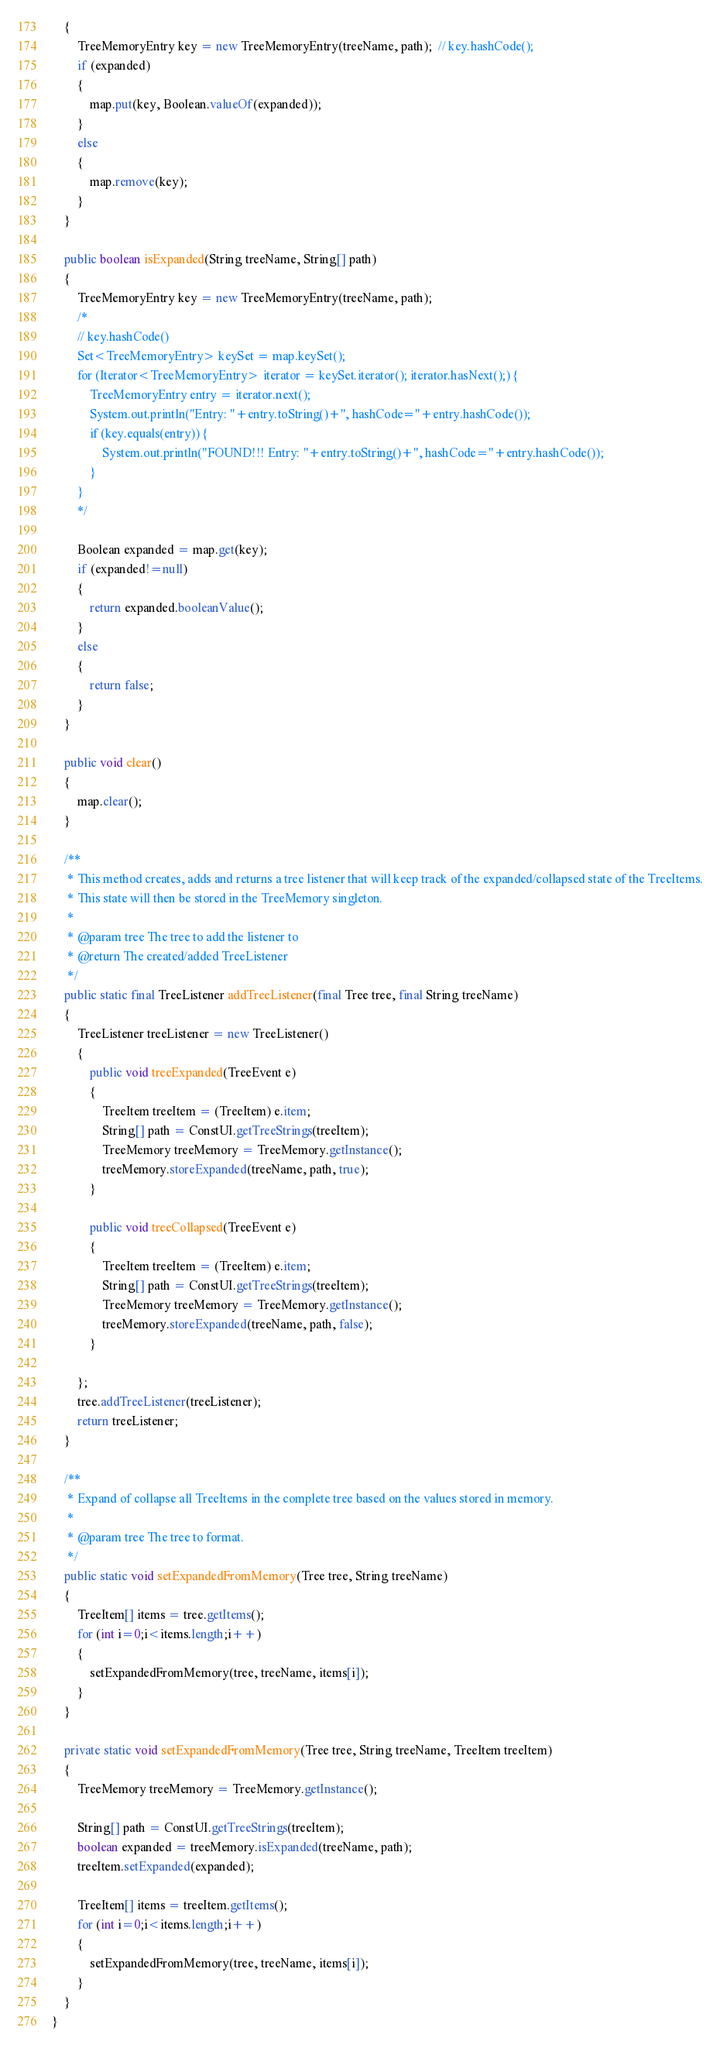<code> <loc_0><loc_0><loc_500><loc_500><_Java_>    {
    	TreeMemoryEntry key = new TreeMemoryEntry(treeName, path);  // key.hashCode();
        if (expanded)
        {
            map.put(key, Boolean.valueOf(expanded));
        }
        else
        {
            map.remove(key);
        }
    }
    
    public boolean isExpanded(String treeName, String[] path)
    {
    	TreeMemoryEntry key = new TreeMemoryEntry(treeName, path);
    	/*
    	// key.hashCode()
    	Set<TreeMemoryEntry> keySet = map.keySet();
    	for (Iterator<TreeMemoryEntry> iterator = keySet.iterator(); iterator.hasNext();) {
			TreeMemoryEntry entry = iterator.next();
			System.out.println("Entry: "+entry.toString()+", hashCode="+entry.hashCode());
			if (key.equals(entry)) {
				System.out.println("FOUND!!! Entry: "+entry.toString()+", hashCode="+entry.hashCode());
			}
		}
    	*/
    	
    	Boolean expanded = map.get(key);
        if (expanded!=null)
        {
            return expanded.booleanValue();
        }
        else
        {
            return false;
        }
    }
    
    public void clear()
    {
        map.clear();
    }

    /**
     * This method creates, adds and returns a tree listener that will keep track of the expanded/collapsed state of the TreeItems.
     * This state will then be stored in the TreeMemory singleton.
     * 
     * @param tree The tree to add the listener to
     * @return The created/added TreeListener
     */
    public static final TreeListener addTreeListener(final Tree tree, final String treeName)
    {
        TreeListener treeListener = new TreeListener()
        {        
            public void treeExpanded(TreeEvent e)
            {
                TreeItem treeItem = (TreeItem) e.item;
                String[] path = ConstUI.getTreeStrings(treeItem);
                TreeMemory treeMemory = TreeMemory.getInstance();
                treeMemory.storeExpanded(treeName, path, true);
            }
        
            public void treeCollapsed(TreeEvent e)
            {
                TreeItem treeItem = (TreeItem) e.item;
                String[] path = ConstUI.getTreeStrings(treeItem);
                TreeMemory treeMemory = TreeMemory.getInstance();
                treeMemory.storeExpanded(treeName, path, false);
            }
        
        };
        tree.addTreeListener(treeListener);
        return treeListener;
    }

    /**
     * Expand of collapse all TreeItems in the complete tree based on the values stored in memory.
     *  
     * @param tree The tree to format.
     */
    public static void setExpandedFromMemory(Tree tree, String treeName)
    {
        TreeItem[] items = tree.getItems();
        for (int i=0;i<items.length;i++)
        {
            setExpandedFromMemory(tree, treeName, items[i]);
        }
    }
    
    private static void setExpandedFromMemory(Tree tree, String treeName, TreeItem treeItem)
    {
        TreeMemory treeMemory = TreeMemory.getInstance();
        
        String[] path = ConstUI.getTreeStrings(treeItem);
        boolean expanded = treeMemory.isExpanded(treeName, path);
        treeItem.setExpanded(expanded);
        
        TreeItem[] items = treeItem.getItems();
        for (int i=0;i<items.length;i++)
        {
            setExpandedFromMemory(tree, treeName, items[i]);
        }
    }
}
</code> 